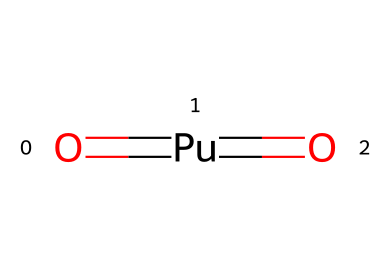how many oxygen atoms are in plutonium dioxide? The SMILES representation clearly indicates two oxygen atoms, represented as "O" in the formula.
Answer: 2 what is the central atom in plutonium dioxide? In the provided SMILES, "Pu" is the central atom connected to two oxygen atoms, indicating it is the central element in the compound.
Answer: plutonium how many total bonds are present in the molecular structure? Each O atom is connected to Pu via a double bond, which counts as 2 bonds for each Oxygen. Therefore, there are 2 double bonds total, making it 4 bonds.
Answer: 4 what type of hybridization does the central atom exhibit? The central Pu atom is likely to exhibit dsp² hybridization due to its coordination with two double-bonded oxygens, a typical characteristic of heavy actinides.
Answer: dsp² what is the molecular geometry of plutonium dioxide? Based on its two double bonds with oxygen atoms, the molecular geometry is linear, as the arrangement of atoms around plutonium allows for minimum electron pair repulsion in a straight line.
Answer: linear is plutonium dioxide a molecular or ionic compound? The compound contains covalent bonds between plutonium and oxygen, indicating it is more characteristic of a molecular compound rather than an ionic one.
Answer: molecular what role does plutonium dioxide play in nuclear applications? Plutonium dioxide is primarily utilized as nuclear fuel due to its fissile properties, which allow it to sustain nuclear reactions.
Answer: nuclear fuel 